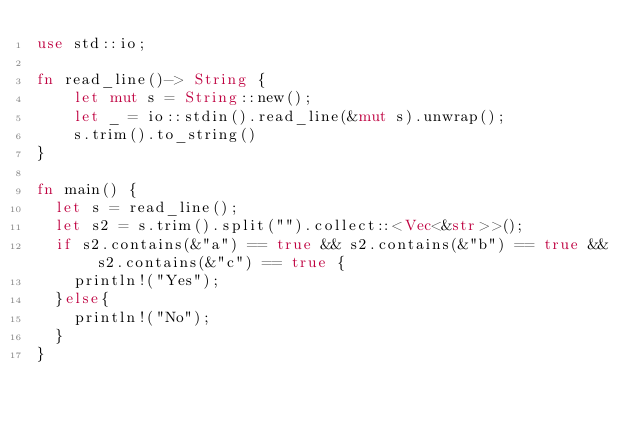<code> <loc_0><loc_0><loc_500><loc_500><_Rust_>use std::io;

fn read_line()-> String {
    let mut s = String::new();
    let _ = io::stdin().read_line(&mut s).unwrap();
    s.trim().to_string()
}

fn main() {
	let s = read_line();
	let s2 = s.trim().split("").collect::<Vec<&str>>();
	if s2.contains(&"a") == true && s2.contains(&"b") == true && s2.contains(&"c") == true {
		println!("Yes");
	}else{
		println!("No");
	}
}
</code> 